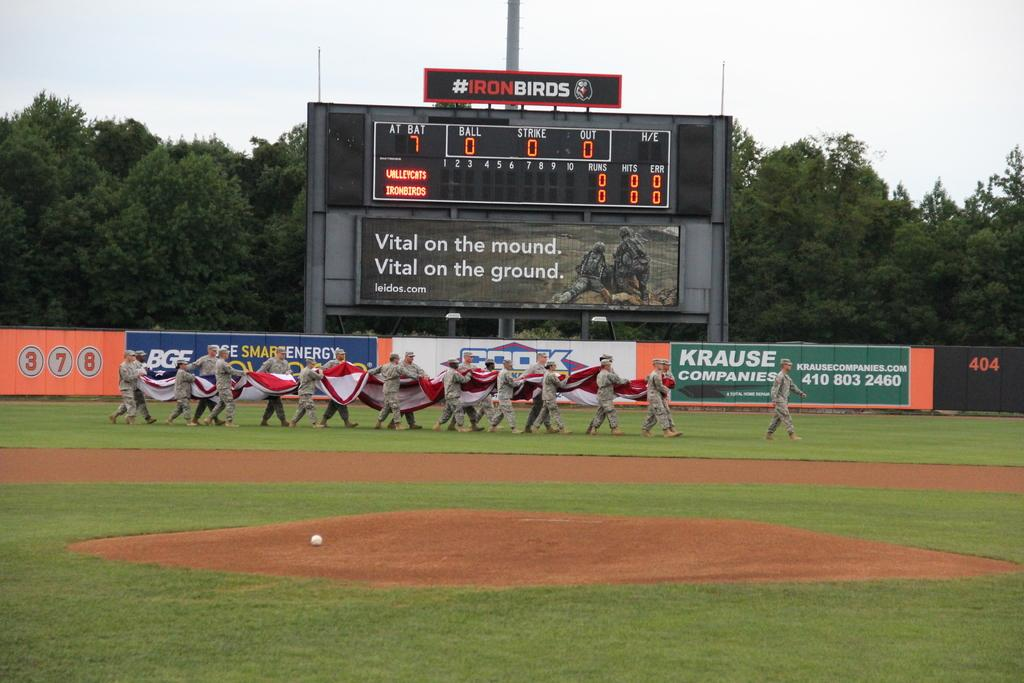<image>
Create a compact narrative representing the image presented. A number of military personnel carry a large flag across the Iron Birds baseball field. 